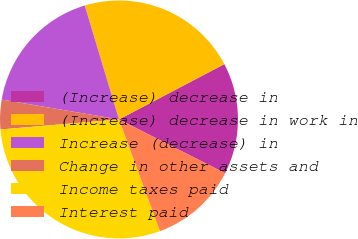Convert chart to OTSL. <chart><loc_0><loc_0><loc_500><loc_500><pie_chart><fcel>(Increase) decrease in<fcel>(Increase) decrease in work in<fcel>Increase (decrease) in<fcel>Change in other assets and<fcel>Income taxes paid<fcel>Interest paid<nl><fcel>15.16%<fcel>21.95%<fcel>17.68%<fcel>4.02%<fcel>29.25%<fcel>11.94%<nl></chart> 